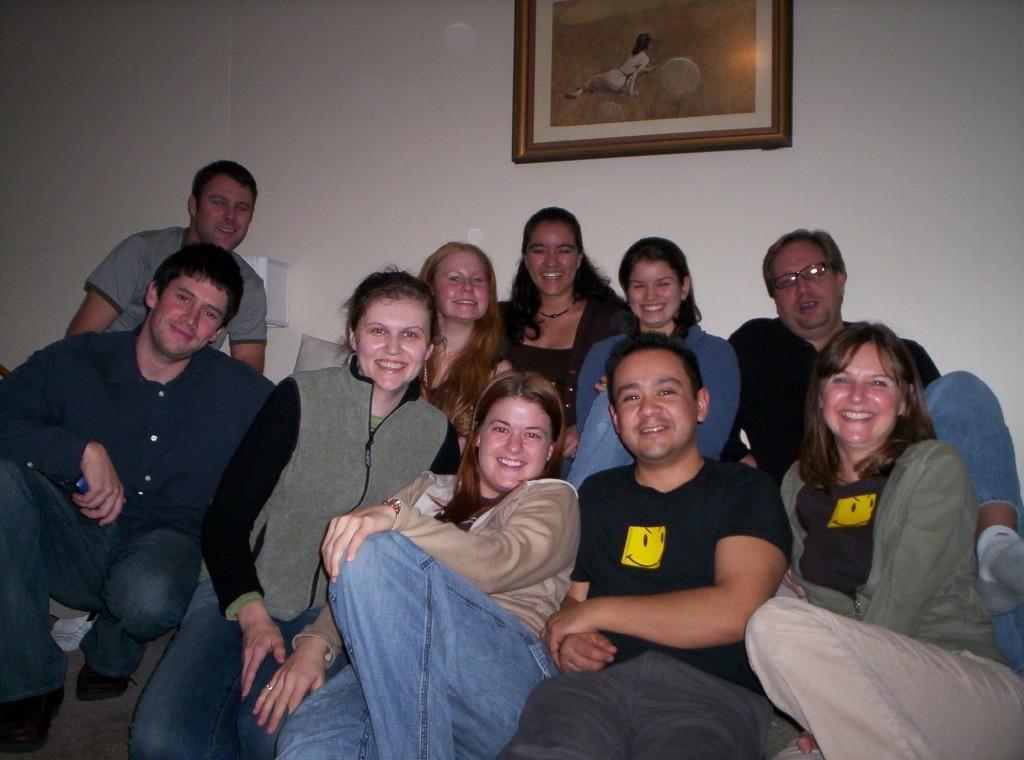Describe this image in one or two sentences. In this image I can see a group of people. In the background, I can see a photo frame on the wall. 